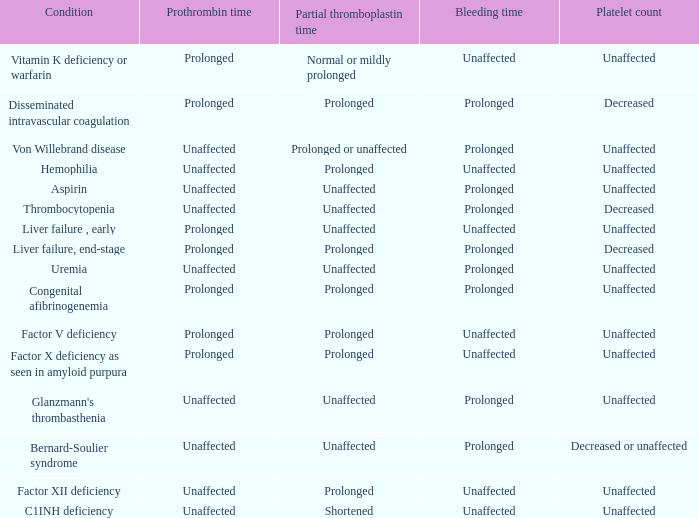Which Bleeding time has a Condition of factor x deficiency as seen in amyloid purpura? Unaffected. 